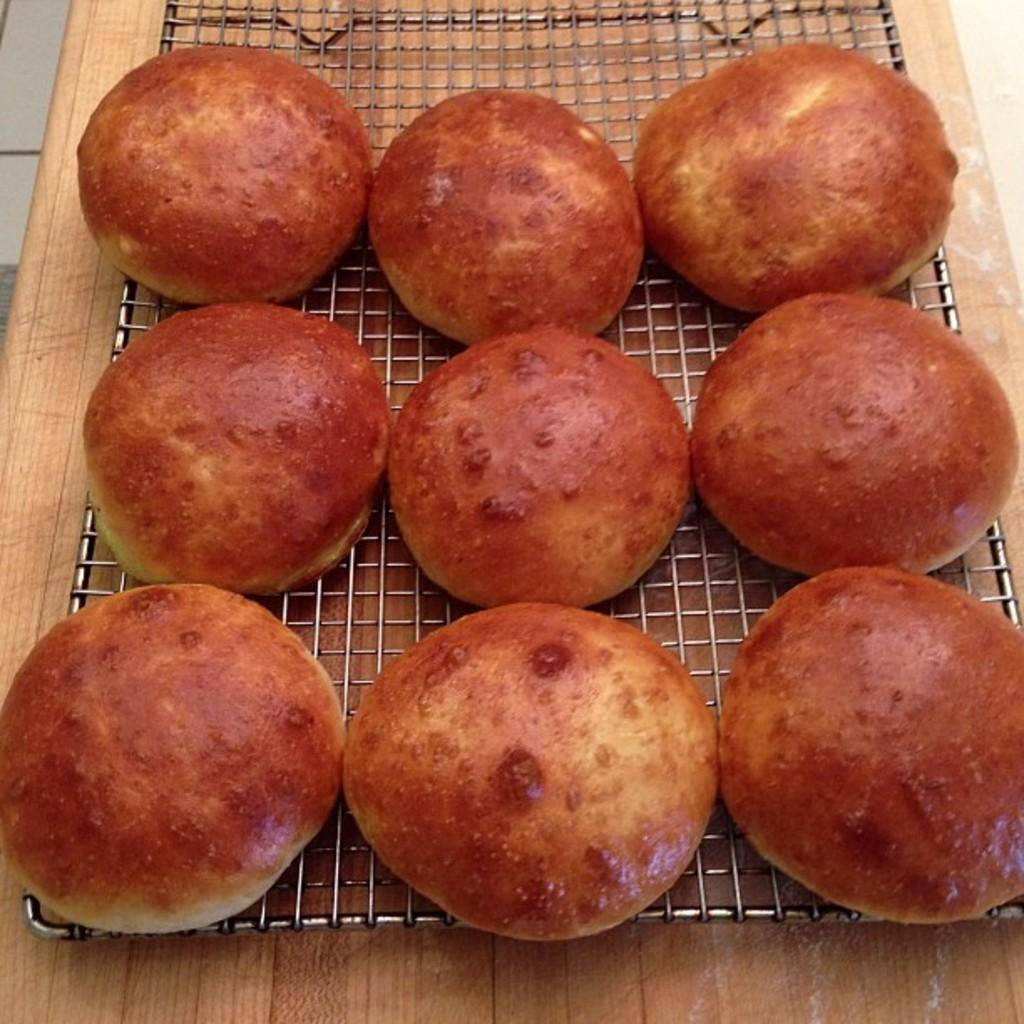How many hot buns are visible in the image? There are 9 hot buns in the image. Where are the hot buns located? The hot buns are on a grill. What type of thunder can be heard in the image? There is no thunder present in the image, as it is a still image of hot buns on a grill. 